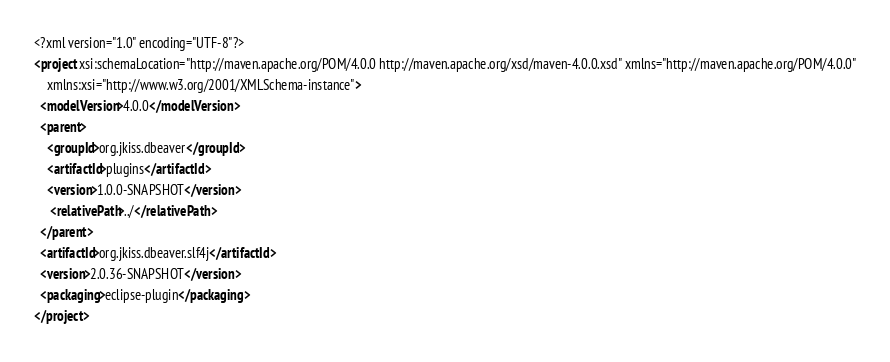Convert code to text. <code><loc_0><loc_0><loc_500><loc_500><_XML_><?xml version="1.0" encoding="UTF-8"?>
<project xsi:schemaLocation="http://maven.apache.org/POM/4.0.0 http://maven.apache.org/xsd/maven-4.0.0.xsd" xmlns="http://maven.apache.org/POM/4.0.0"
    xmlns:xsi="http://www.w3.org/2001/XMLSchema-instance">
  <modelVersion>4.0.0</modelVersion>
  <parent>
    <groupId>org.jkiss.dbeaver</groupId>
    <artifactId>plugins</artifactId>
    <version>1.0.0-SNAPSHOT</version>
     <relativePath>../</relativePath>
  </parent>
  <artifactId>org.jkiss.dbeaver.slf4j</artifactId>
  <version>2.0.36-SNAPSHOT</version>
  <packaging>eclipse-plugin</packaging>
</project>
</code> 